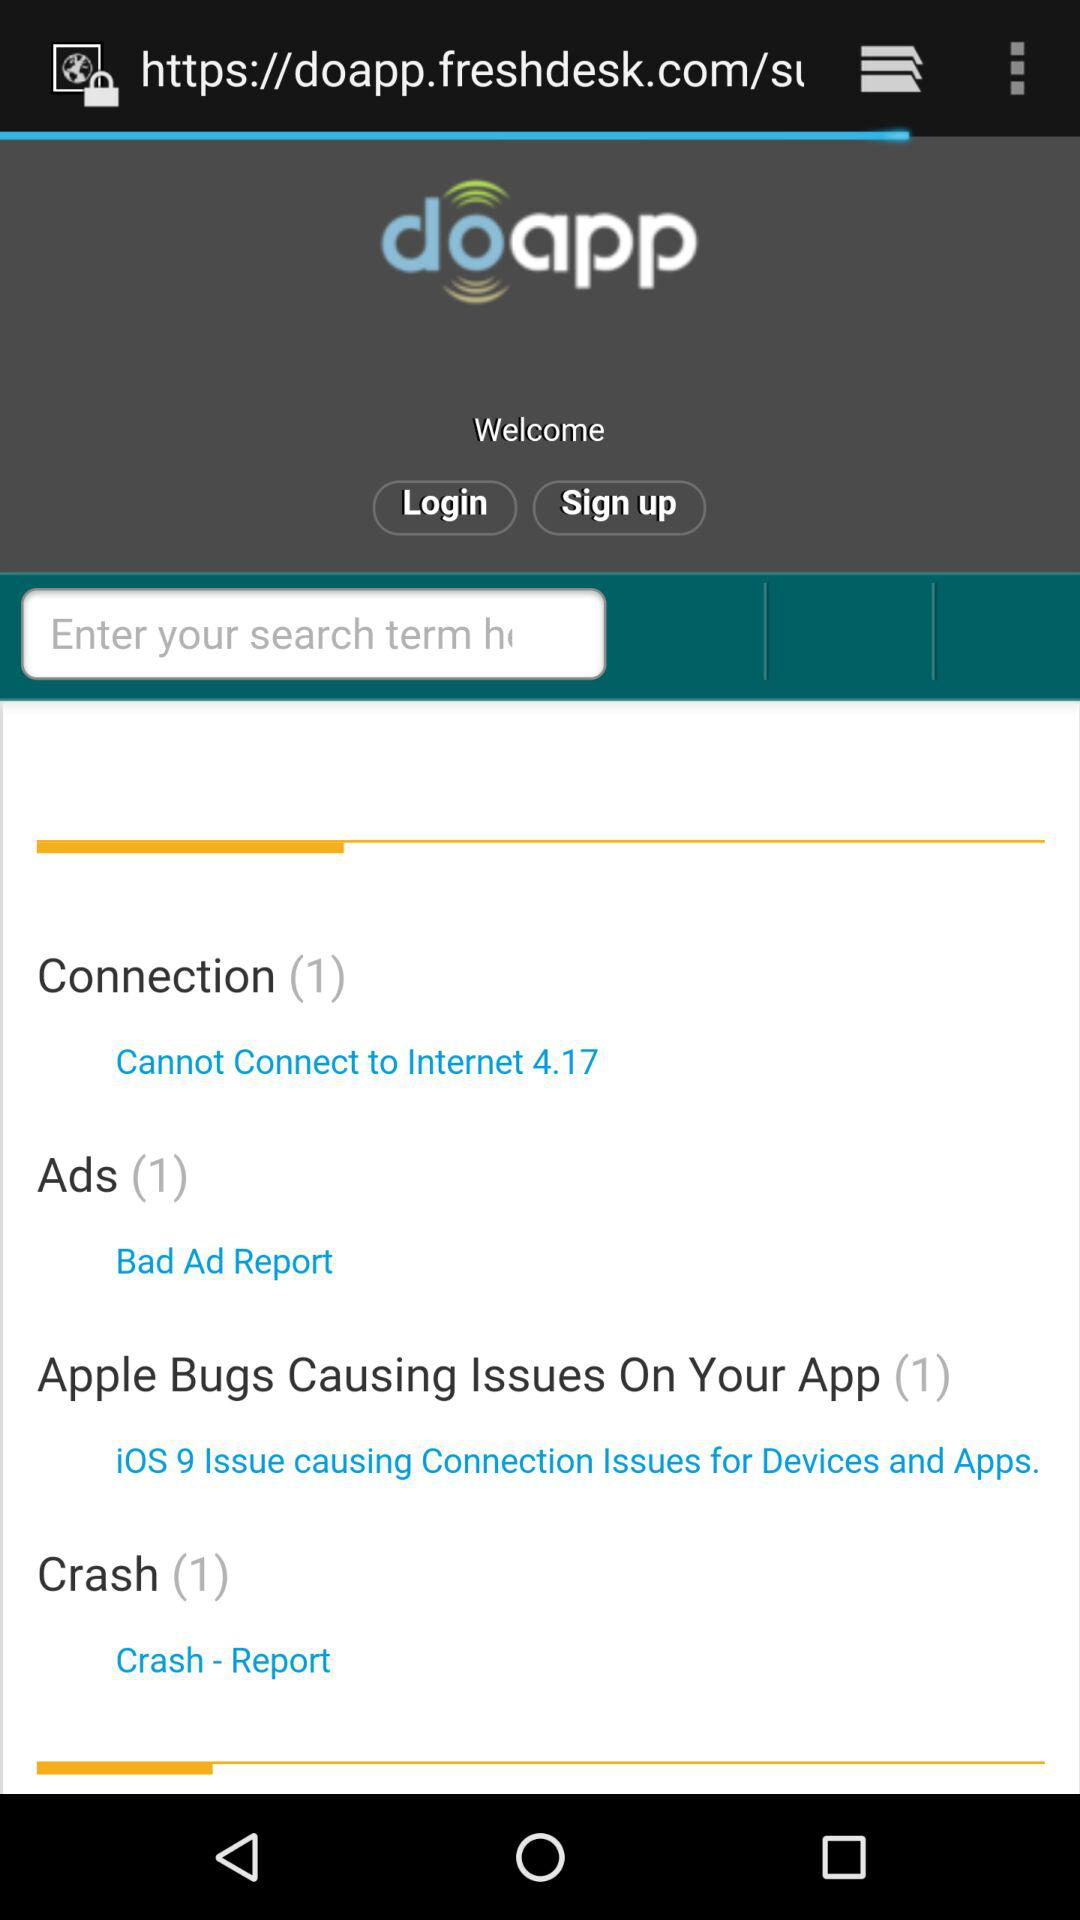What operating system is causing connection issues for devices and applications? The operating system that is causing connection issues for devices and applications is "i0S". 